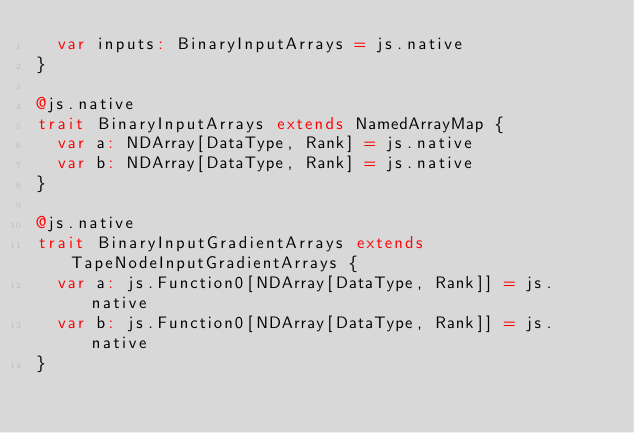Convert code to text. <code><loc_0><loc_0><loc_500><loc_500><_Scala_>  var inputs: BinaryInputArrays = js.native
}

@js.native
trait BinaryInputArrays extends NamedArrayMap {
  var a: NDArray[DataType, Rank] = js.native
  var b: NDArray[DataType, Rank] = js.native
}

@js.native
trait BinaryInputGradientArrays extends TapeNodeInputGradientArrays {
  var a: js.Function0[NDArray[DataType, Rank]] = js.native
  var b: js.Function0[NDArray[DataType, Rank]] = js.native
}
</code> 